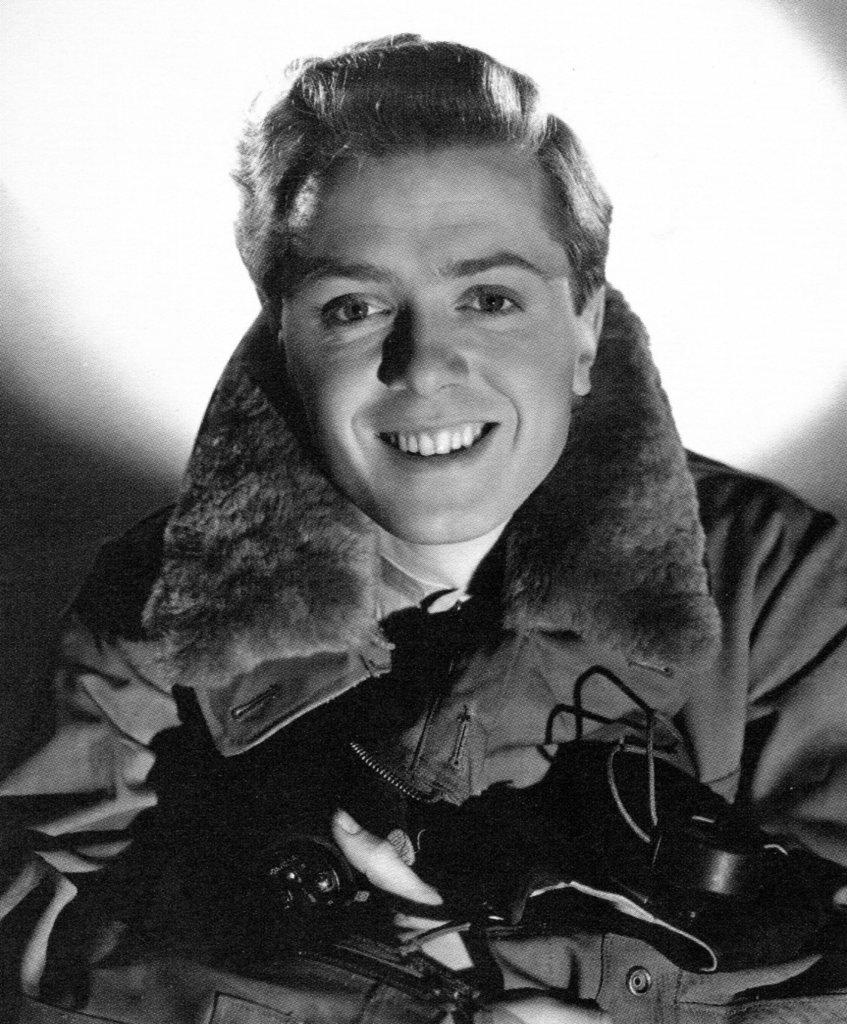Who is present in the image? There is a man in the image. What is the man holding in his hand? The man is holding an object in his hand. What can be observed about the background of the image? The background of the image appears to be white. Can we determine the location where the image was taken? The image may have been taken in a room, based on the white background. How does the man express pain in the image? There is no indication of pain in the image; the man is simply holding an object in his hand. 